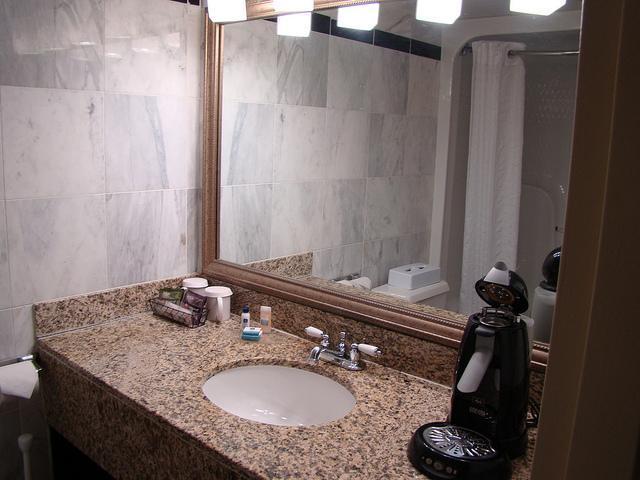How many sinks are in the picture?
Give a very brief answer. 2. 